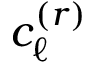Convert formula to latex. <formula><loc_0><loc_0><loc_500><loc_500>c _ { \ell } ^ { ( r ) }</formula> 